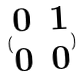<formula> <loc_0><loc_0><loc_500><loc_500>( \begin{matrix} 0 & 1 \\ 0 & 0 \end{matrix} )</formula> 